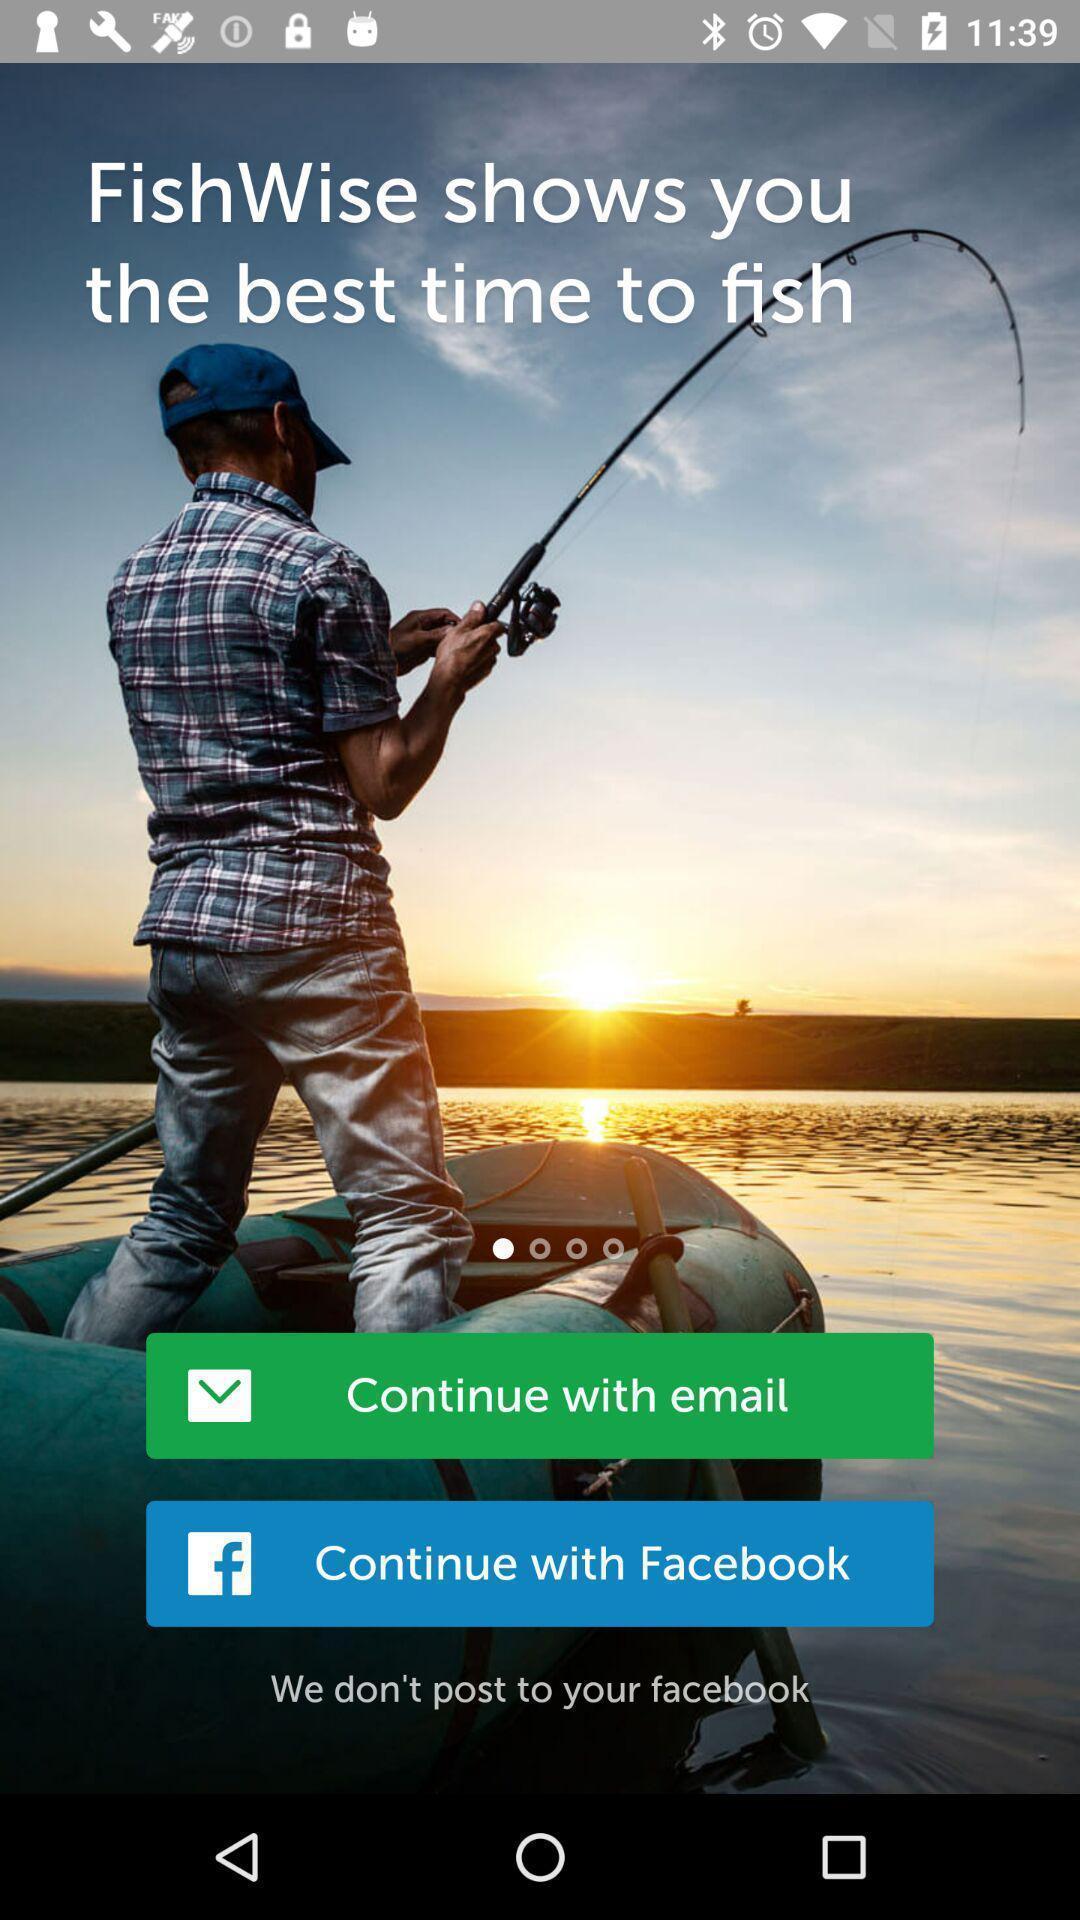Give me a summary of this screen capture. Welcome page. 